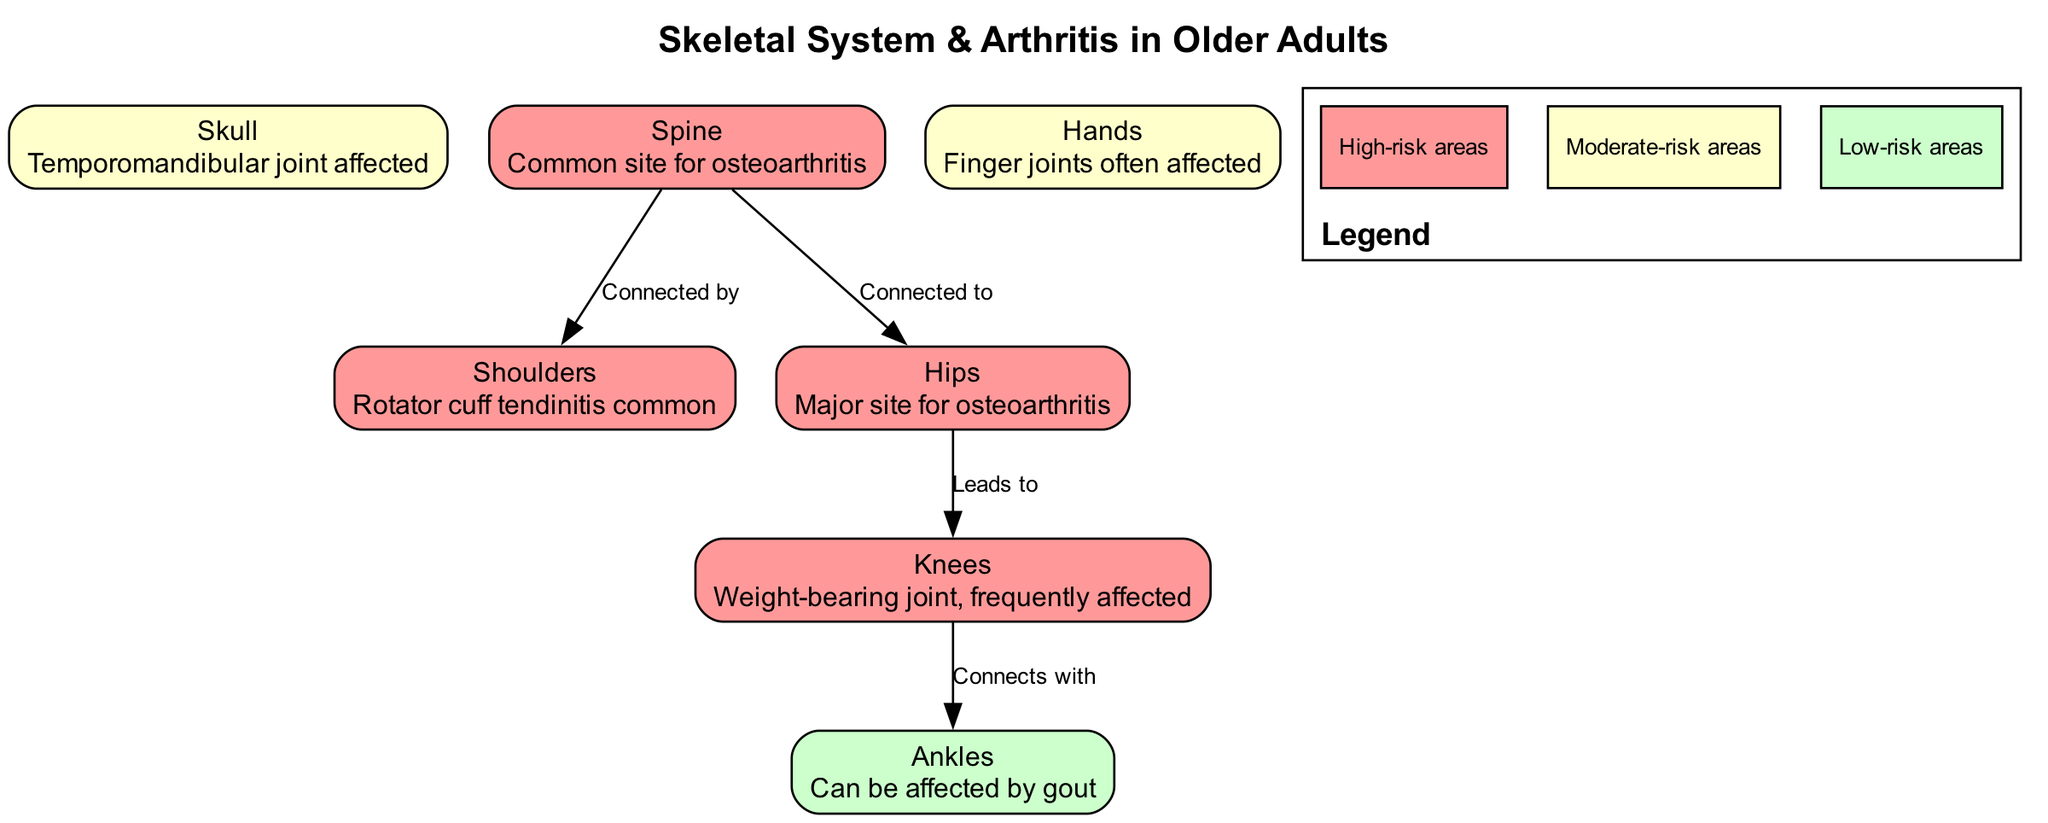What part of the skeletal system is affected by temporomandibular joint issues? According to the diagram, the skull is highlighted with a note indicating that the temporomandibular joint is affected.
Answer: Skull Which joint is commonly associated with osteoarthritis? The diagram notes that the spine is a common site for osteoarthritis, explicitly indicating that this is a key area affected by the condition.
Answer: Spine How many high-risk areas are identified in the diagram? The diagram lists the nodes with high-risk areas specifically related to arthritis. There are three nodes marked as high-risk areas: the spine, hips, and knees.
Answer: 3 Which section of the skeletal system connects the hips and knees? The diagram indicates a relationship between the hips and knees, showing that directly from the hips, there is a lead to the knees, establishing a connection between these two parts.
Answer: Hips What is the risk level of the ankles as depicted in the diagram? The note regarding the ankles states that they can be affected by gout, which suggests that they are classified as a low-risk area for arthritis, as noted in the diagram.
Answer: Low-risk areas What structure is connected to the shoulders in the diagram? The diagram indicates that the spine is connected to the shoulders, showing a direct relationship between these two parts of the skeletal system.
Answer: Spine Which joints are frequently affected due to weight-bearing? The diagram highlights that the knees, as a weight-bearing joint, are frequently affected by arthritis, illustrating their importance in the skeletal system regarding arthritis.
Answer: Knees What color represents high-risk areas in the legend? The legend in the diagram describes high-risk areas as being marked in red. This color indicates the parts of the skeletal system that are most susceptible to arthritis in older adults.
Answer: Red In the diagram, what leads to the ankles? The connection from the knees indicates that they connect with the ankles according to the edges shown in the diagram, demonstrating a link in the skeletal system related to arthritis.
Answer: Knees 